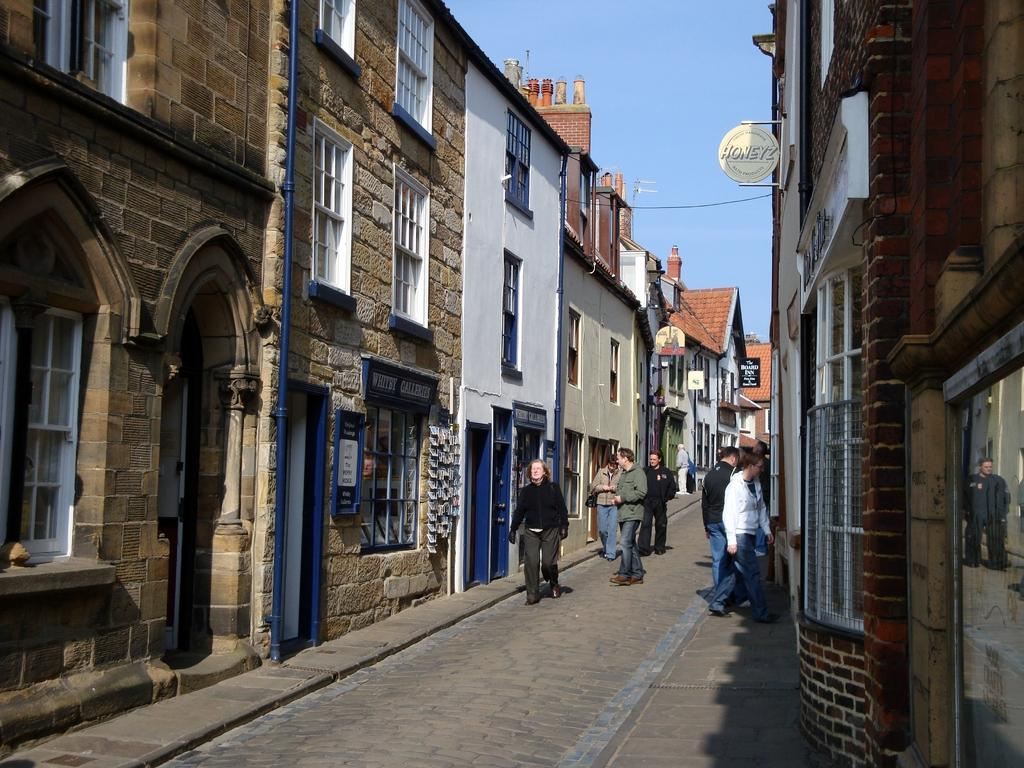What can be seen on the pathway in the image? There is a group of people on a pathway in the image. What type of structures are visible in the image? There are buildings with windows in the image. What information might be conveyed by the sign boards in the image? The sign boards with text in the image might convey information or directions. What is the condition of the sky in the image? The sky is visible and appears cloudy in the image. What type of bed can be seen in the image? There is no bed present in the image. How many glasses of water are visible in the image? There are no glasses of water present in the image. 